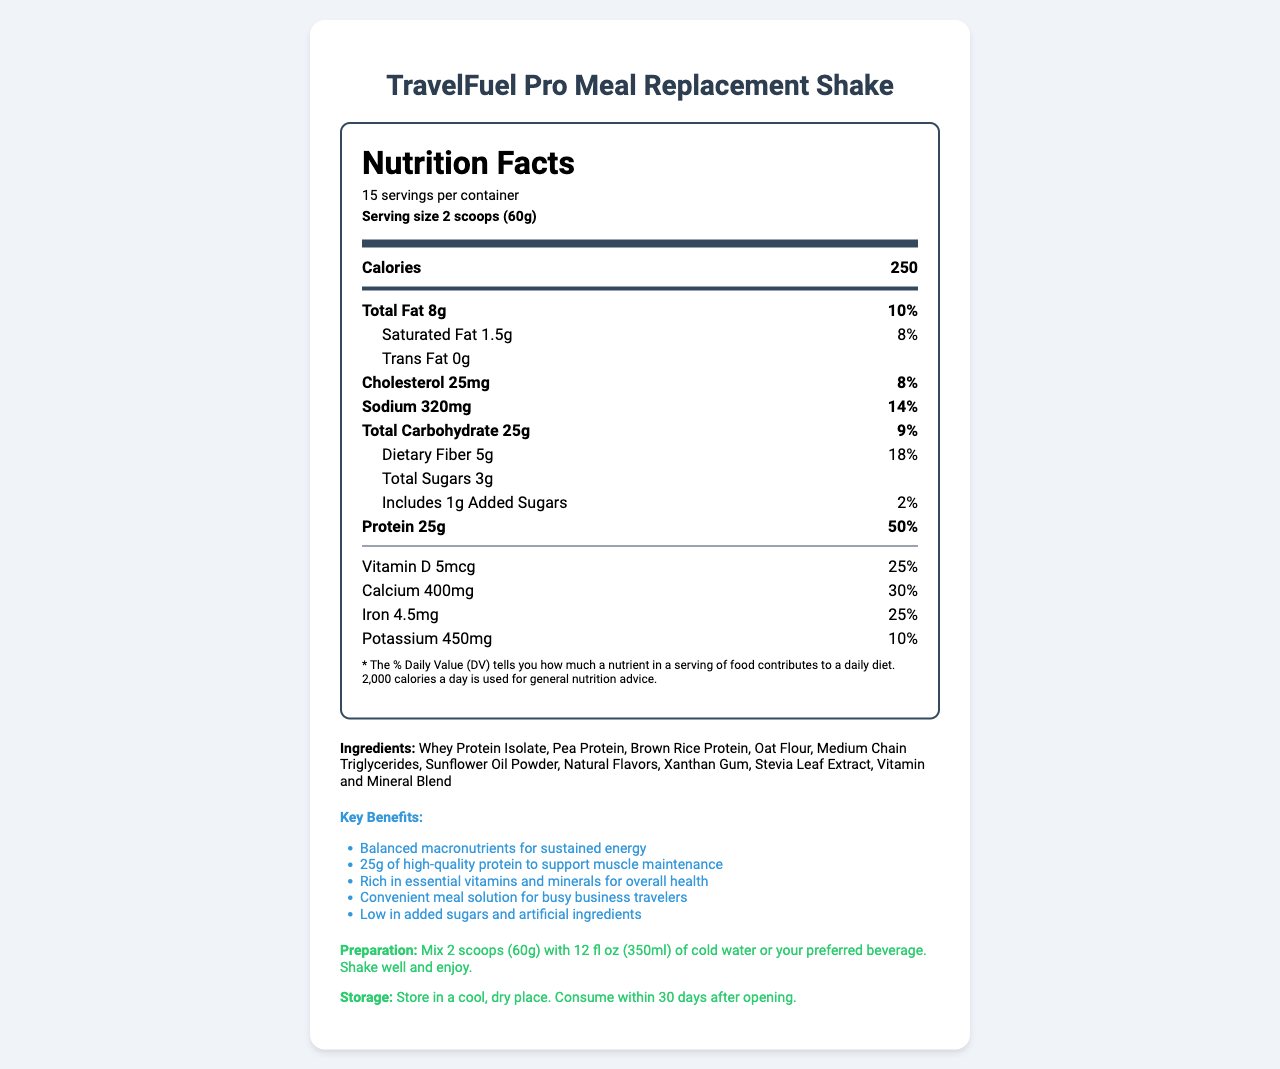what is the serving size of the TravelFuel Pro Meal Replacement Shake? The serving size is clearly stated near the top of the Nutrition Facts label: "Serving size 2 scoops (60g)."
Answer: 2 scoops (60g) how many servings are in one container of TravelFuel Pro? The number of servings per container is listed just below the product name: "15 servings per container."
Answer: 15 how many calories are in one serving? The calorie count per serving is displayed prominently: "250" under the "Calories" section.
Answer: 250 how much protein does each serving contain? The amount of protein per serving is listed as "25g."
Answer: 25g what percentage of your daily iron needs are met by one serving? The % Daily Value for iron is shown as "25%."
Answer: 25% how much total fat is in one serving of the shake? Total fat per serving is listed as "8g."
Answer: 8g how many grams of sugar are in one serving? A. 1g B. 3g C. 5g D. 25g The total sugars per serving are listed as "3g."
Answer: B what is the main fat source in the ingredients list? A. Whey Protein Isolate B. Medium Chain Triglycerides C. Sunflower Oil Powder Sunflower Oil Powder is listed among the ingredients as a fat source.
Answer: C does the product contain any artificial ingredients? The marketing claims state "Low in added sugars and artificial ingredients," indicating no artificial ingredients are included.
Answer: No is the TravelFuel Pro shake suitable for someone with a nut allergy? The allergen info says "Manufactured in a facility that also processes soy, egg, tree nuts, and wheat," which does not guarantee it’s nut-free.
Answer: Not enough information which vitamin has the highest % Daily Value in one serving of the shake? A. Vitamin D B. Vitamin A C. Vitamin C D. Vitamin B12 Vitamin A, Vitamin C, Vitamin E, Vitamin K, and others are listed with 50%, but Vitamin A is the first listed under vitamins with 50%.
Answer: B how should the TravelFuel Pro Meal Replacement Shake be stored after opening? Storage instructions are provided at the bottom: "Store in a cool, dry place. Consume within 30 days after opening."
Answer: Store in a cool, dry place. Consume within 30 days after opening. is this meal replacement shake marketed specifically for business travelers? One of the marketing claims states, "Convenient meal solution for busy business travelers."
Answer: Yes summarize the main purpose of this document. The document contains detailed nutritional information, an ingredient list, allergen information, marketing claims, and instructions on how to prepare and store the shake. It emphasizes the product’s balanced composition and convenience for business travelers.
Answer: The document provides the nutrition facts, ingredients, and preparation/storage instructions for the TravelFuel Pro Meal Replacement Shake, highlighting its balanced macronutrients, high protein content, and suitability for business travelers. 